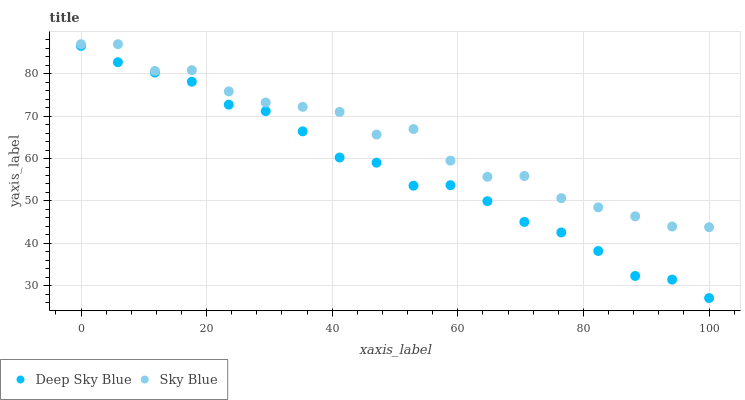Does Deep Sky Blue have the minimum area under the curve?
Answer yes or no. Yes. Does Sky Blue have the maximum area under the curve?
Answer yes or no. Yes. Does Deep Sky Blue have the maximum area under the curve?
Answer yes or no. No. Is Deep Sky Blue the smoothest?
Answer yes or no. Yes. Is Sky Blue the roughest?
Answer yes or no. Yes. Is Deep Sky Blue the roughest?
Answer yes or no. No. Does Deep Sky Blue have the lowest value?
Answer yes or no. Yes. Does Sky Blue have the highest value?
Answer yes or no. Yes. Does Deep Sky Blue have the highest value?
Answer yes or no. No. Is Deep Sky Blue less than Sky Blue?
Answer yes or no. Yes. Is Sky Blue greater than Deep Sky Blue?
Answer yes or no. Yes. Does Deep Sky Blue intersect Sky Blue?
Answer yes or no. No. 